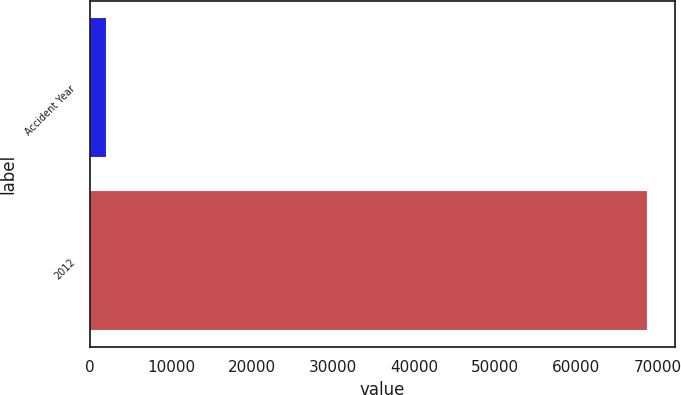<chart> <loc_0><loc_0><loc_500><loc_500><bar_chart><fcel>Accident Year<fcel>2012<nl><fcel>2012<fcel>68742<nl></chart> 